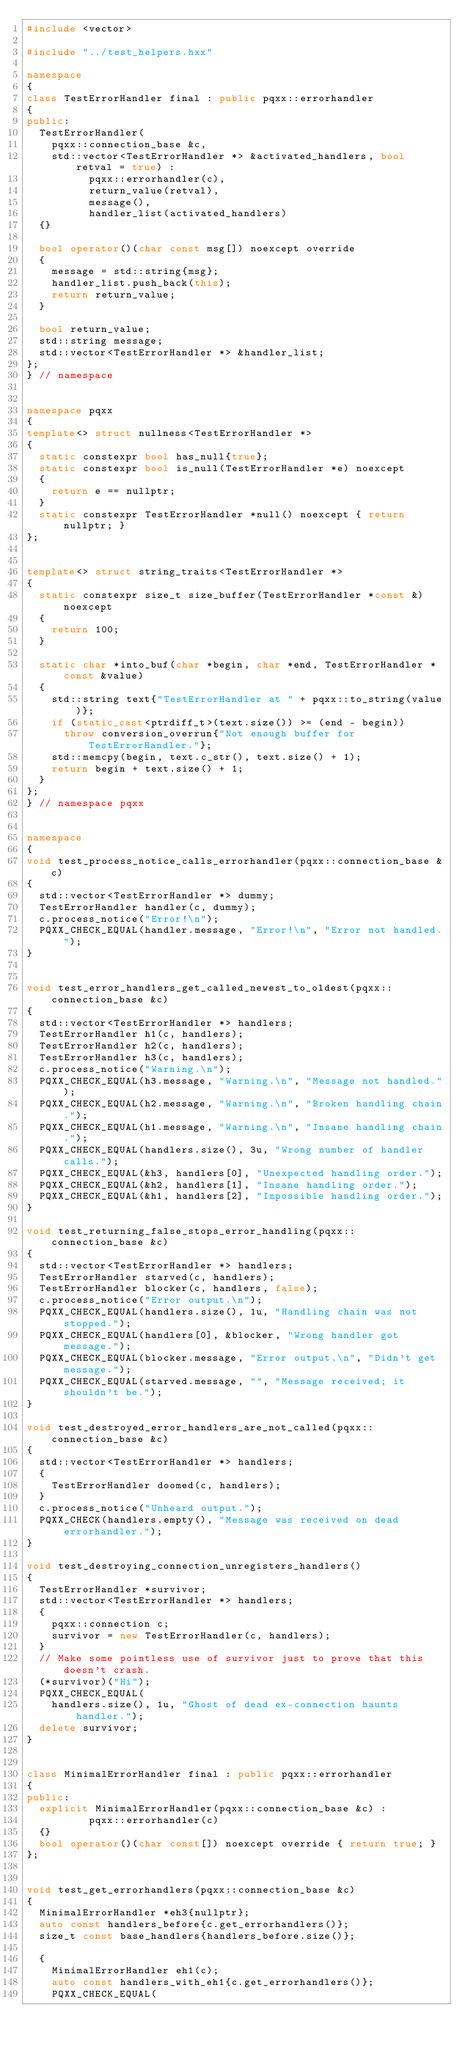Convert code to text. <code><loc_0><loc_0><loc_500><loc_500><_C++_>#include <vector>

#include "../test_helpers.hxx"

namespace
{
class TestErrorHandler final : public pqxx::errorhandler
{
public:
  TestErrorHandler(
    pqxx::connection_base &c,
    std::vector<TestErrorHandler *> &activated_handlers, bool retval = true) :
          pqxx::errorhandler(c),
          return_value(retval),
          message(),
          handler_list(activated_handlers)
  {}

  bool operator()(char const msg[]) noexcept override
  {
    message = std::string{msg};
    handler_list.push_back(this);
    return return_value;
  }

  bool return_value;
  std::string message;
  std::vector<TestErrorHandler *> &handler_list;
};
} // namespace


namespace pqxx
{
template<> struct nullness<TestErrorHandler *>
{
  static constexpr bool has_null{true};
  static constexpr bool is_null(TestErrorHandler *e) noexcept
  {
    return e == nullptr;
  }
  static constexpr TestErrorHandler *null() noexcept { return nullptr; }
};


template<> struct string_traits<TestErrorHandler *>
{
  static constexpr size_t size_buffer(TestErrorHandler *const &) noexcept
  {
    return 100;
  }

  static char *into_buf(char *begin, char *end, TestErrorHandler *const &value)
  {
    std::string text{"TestErrorHandler at " + pqxx::to_string(value)};
    if (static_cast<ptrdiff_t>(text.size()) >= (end - begin))
      throw conversion_overrun{"Not enough buffer for TestErrorHandler."};
    std::memcpy(begin, text.c_str(), text.size() + 1);
    return begin + text.size() + 1;
  }
};
} // namespace pqxx


namespace
{
void test_process_notice_calls_errorhandler(pqxx::connection_base &c)
{
  std::vector<TestErrorHandler *> dummy;
  TestErrorHandler handler(c, dummy);
  c.process_notice("Error!\n");
  PQXX_CHECK_EQUAL(handler.message, "Error!\n", "Error not handled.");
}


void test_error_handlers_get_called_newest_to_oldest(pqxx::connection_base &c)
{
  std::vector<TestErrorHandler *> handlers;
  TestErrorHandler h1(c, handlers);
  TestErrorHandler h2(c, handlers);
  TestErrorHandler h3(c, handlers);
  c.process_notice("Warning.\n");
  PQXX_CHECK_EQUAL(h3.message, "Warning.\n", "Message not handled.");
  PQXX_CHECK_EQUAL(h2.message, "Warning.\n", "Broken handling chain.");
  PQXX_CHECK_EQUAL(h1.message, "Warning.\n", "Insane handling chain.");
  PQXX_CHECK_EQUAL(handlers.size(), 3u, "Wrong number of handler calls.");
  PQXX_CHECK_EQUAL(&h3, handlers[0], "Unexpected handling order.");
  PQXX_CHECK_EQUAL(&h2, handlers[1], "Insane handling order.");
  PQXX_CHECK_EQUAL(&h1, handlers[2], "Impossible handling order.");
}

void test_returning_false_stops_error_handling(pqxx::connection_base &c)
{
  std::vector<TestErrorHandler *> handlers;
  TestErrorHandler starved(c, handlers);
  TestErrorHandler blocker(c, handlers, false);
  c.process_notice("Error output.\n");
  PQXX_CHECK_EQUAL(handlers.size(), 1u, "Handling chain was not stopped.");
  PQXX_CHECK_EQUAL(handlers[0], &blocker, "Wrong handler got message.");
  PQXX_CHECK_EQUAL(blocker.message, "Error output.\n", "Didn't get message.");
  PQXX_CHECK_EQUAL(starved.message, "", "Message received; it shouldn't be.");
}

void test_destroyed_error_handlers_are_not_called(pqxx::connection_base &c)
{
  std::vector<TestErrorHandler *> handlers;
  {
    TestErrorHandler doomed(c, handlers);
  }
  c.process_notice("Unheard output.");
  PQXX_CHECK(handlers.empty(), "Message was received on dead errorhandler.");
}

void test_destroying_connection_unregisters_handlers()
{
  TestErrorHandler *survivor;
  std::vector<TestErrorHandler *> handlers;
  {
    pqxx::connection c;
    survivor = new TestErrorHandler(c, handlers);
  }
  // Make some pointless use of survivor just to prove that this doesn't crash.
  (*survivor)("Hi");
  PQXX_CHECK_EQUAL(
    handlers.size(), 1u, "Ghost of dead ex-connection haunts handler.");
  delete survivor;
}


class MinimalErrorHandler final : public pqxx::errorhandler
{
public:
  explicit MinimalErrorHandler(pqxx::connection_base &c) :
          pqxx::errorhandler(c)
  {}
  bool operator()(char const[]) noexcept override { return true; }
};


void test_get_errorhandlers(pqxx::connection_base &c)
{
  MinimalErrorHandler *eh3{nullptr};
  auto const handlers_before{c.get_errorhandlers()};
  size_t const base_handlers{handlers_before.size()};

  {
    MinimalErrorHandler eh1(c);
    auto const handlers_with_eh1{c.get_errorhandlers()};
    PQXX_CHECK_EQUAL(</code> 